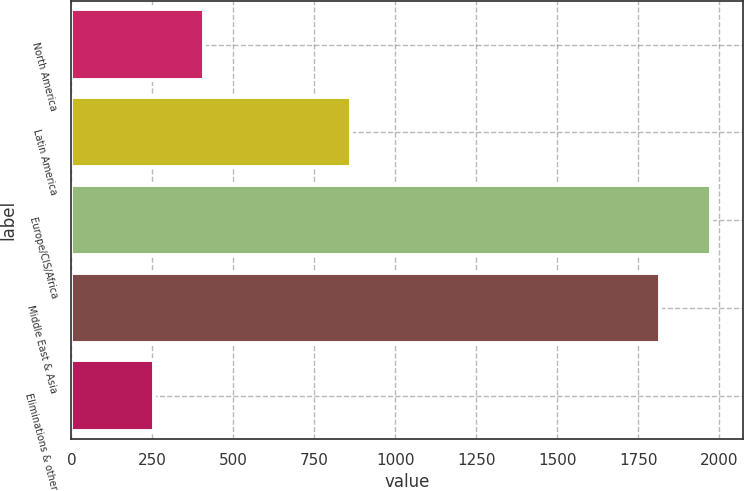<chart> <loc_0><loc_0><loc_500><loc_500><bar_chart><fcel>North America<fcel>Latin America<fcel>Europe/CIS/Africa<fcel>Middle East & Asia<fcel>Eliminations & other<nl><fcel>410.7<fcel>864<fcel>1973.7<fcel>1817<fcel>254<nl></chart> 